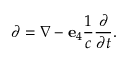<formula> <loc_0><loc_0><loc_500><loc_500>\partial = \nabla - e _ { 4 } { \frac { 1 } { c } } { \frac { \partial } { \partial t } } .</formula> 